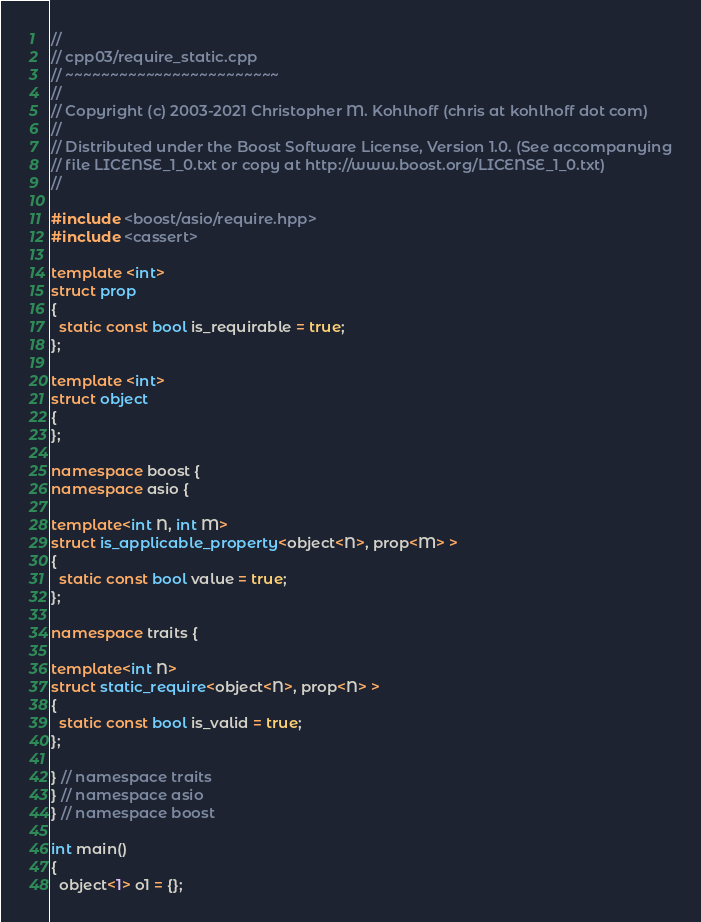Convert code to text. <code><loc_0><loc_0><loc_500><loc_500><_C++_>//
// cpp03/require_static.cpp
// ~~~~~~~~~~~~~~~~~~~~~~~~
//
// Copyright (c) 2003-2021 Christopher M. Kohlhoff (chris at kohlhoff dot com)
//
// Distributed under the Boost Software License, Version 1.0. (See accompanying
// file LICENSE_1_0.txt or copy at http://www.boost.org/LICENSE_1_0.txt)
//

#include <boost/asio/require.hpp>
#include <cassert>

template <int>
struct prop
{
  static const bool is_requirable = true;
};

template <int>
struct object
{
};

namespace boost {
namespace asio {

template<int N, int M>
struct is_applicable_property<object<N>, prop<M> >
{
  static const bool value = true;
};

namespace traits {

template<int N>
struct static_require<object<N>, prop<N> >
{
  static const bool is_valid = true;
};

} // namespace traits
} // namespace asio
} // namespace boost

int main()
{
  object<1> o1 = {};</code> 